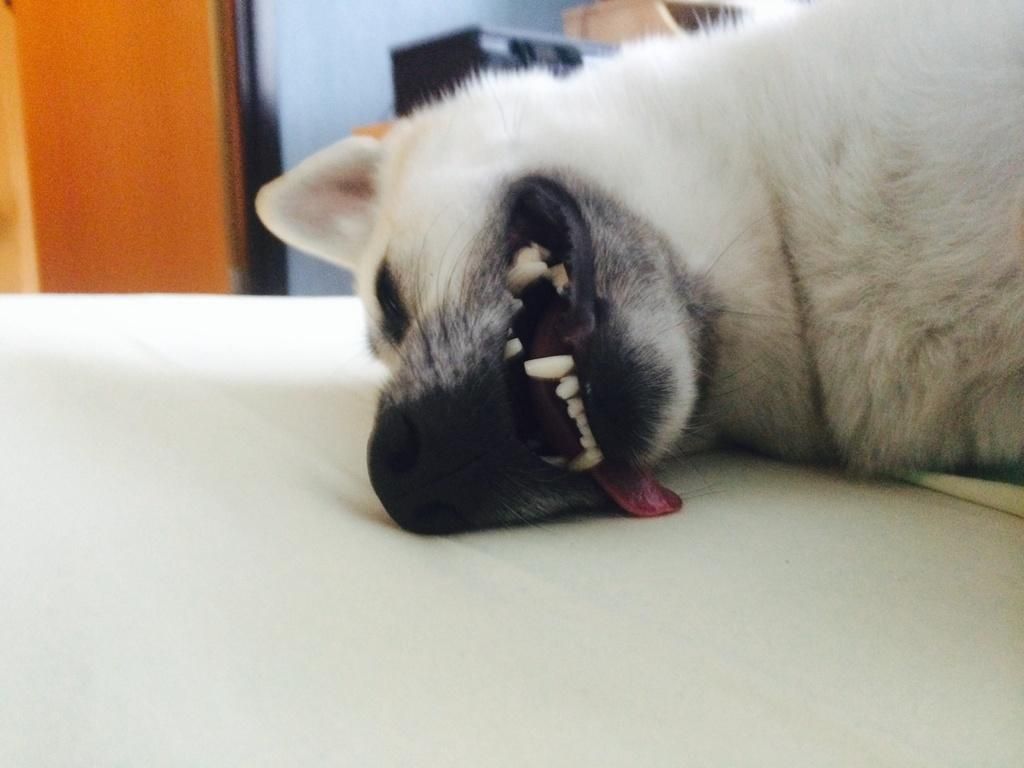What type of animal is in the image? There is a white color dog in the image. What is the color of the surface the dog is on? The dog is on a white color surface. Can you describe the background of the image? The background of the image has brown and blue colors. How many people are in the crowd behind the dog in the image? There is no crowd present in the image; it only features a white color dog on a white color surface with a brown and blue background. 